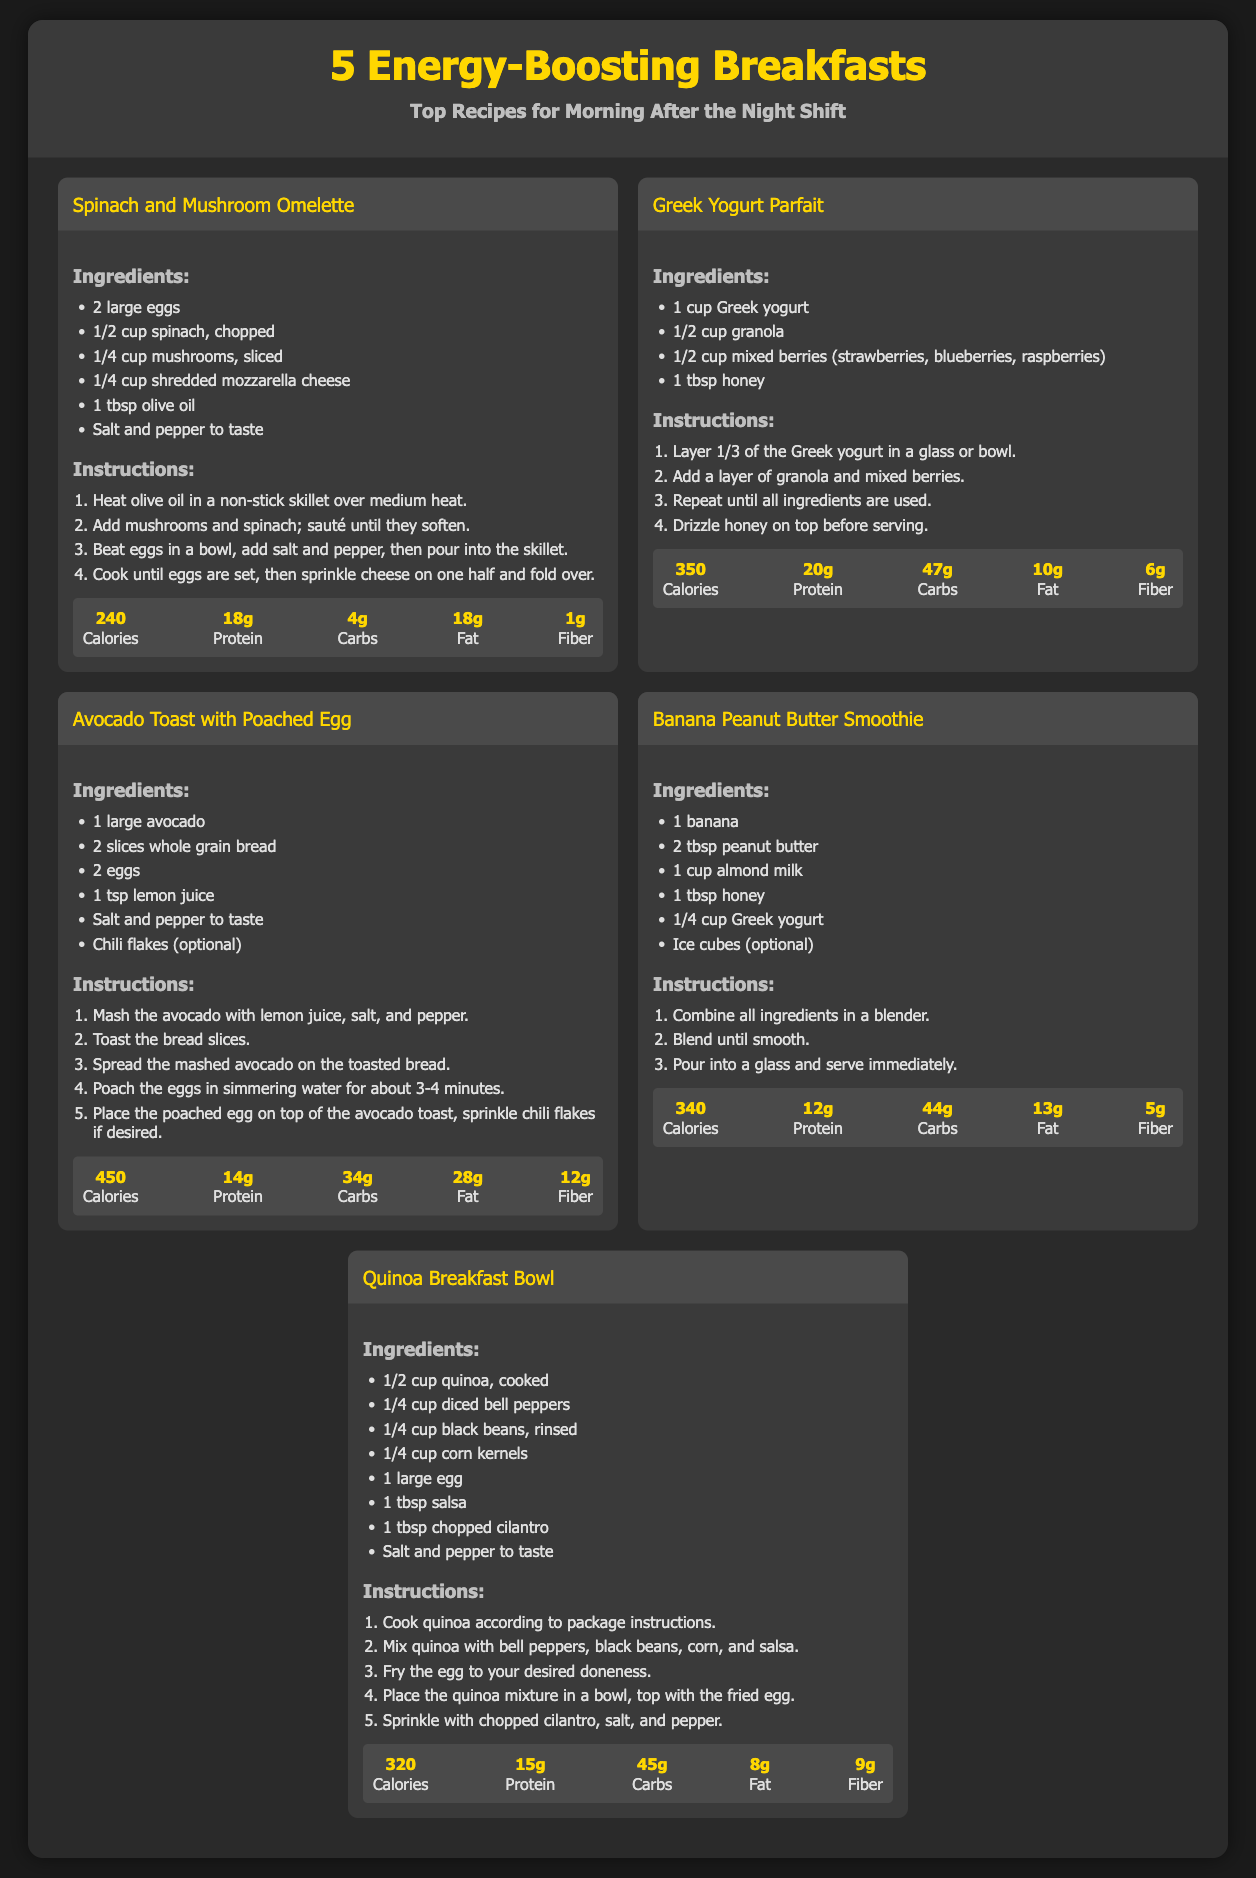What is the title of the infographic? The title is typically stated at the top of the document, and it is "5 Energy-Boosting Breakfasts".
Answer: 5 Energy-Boosting Breakfasts How many breakfast recipes are included? The number of recipes can be counted in the document; there are five listed.
Answer: 5 What ingredient is used in the Spinach and Mushroom Omelette? The ingredients for the omelette can be observed, and one of them is "eggs".
Answer: eggs What is the calorie count for the Greek Yogurt Parfait? Nutrition information specifies the calorie count of the parfait as stated in the document.
Answer: 350 Which recipe has avocado as an ingredient? The recipes can be analyzed to determine which includes avocado, specifically the "Avocado Toast with Poached Egg".
Answer: Avocado Toast with Poached Egg Which recipe requires blending ingredients? Reasoning based on recipe instructions indicates that the "Banana Peanut Butter Smoothie" requires blending.
Answer: Banana Peanut Butter Smoothie What is the main grain used in the Quinoa Breakfast Bowl? The main ingredient can be identified from the recipe, which is quinoa.
Answer: quinoa What cooking method is suggested for the eggs in the Avocado Toast recipe? The instructions detail how the eggs should be prepared, mentioning "poached".
Answer: poached What is the total protein amount in the Spinach and Mushroom Omelette? The nutritional values listed state the protein amount for this dish.
Answer: 18g 